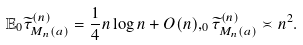Convert formula to latex. <formula><loc_0><loc_0><loc_500><loc_500>\mathbb { E } _ { 0 } \widetilde { \tau } ^ { ( n ) } _ { M _ { n } ( a ) } = \frac { 1 } { 4 } n \log n + O ( n ) , _ { 0 } \widetilde { \tau } ^ { ( n ) } _ { M _ { n } ( a ) } \asymp n ^ { 2 } .</formula> 